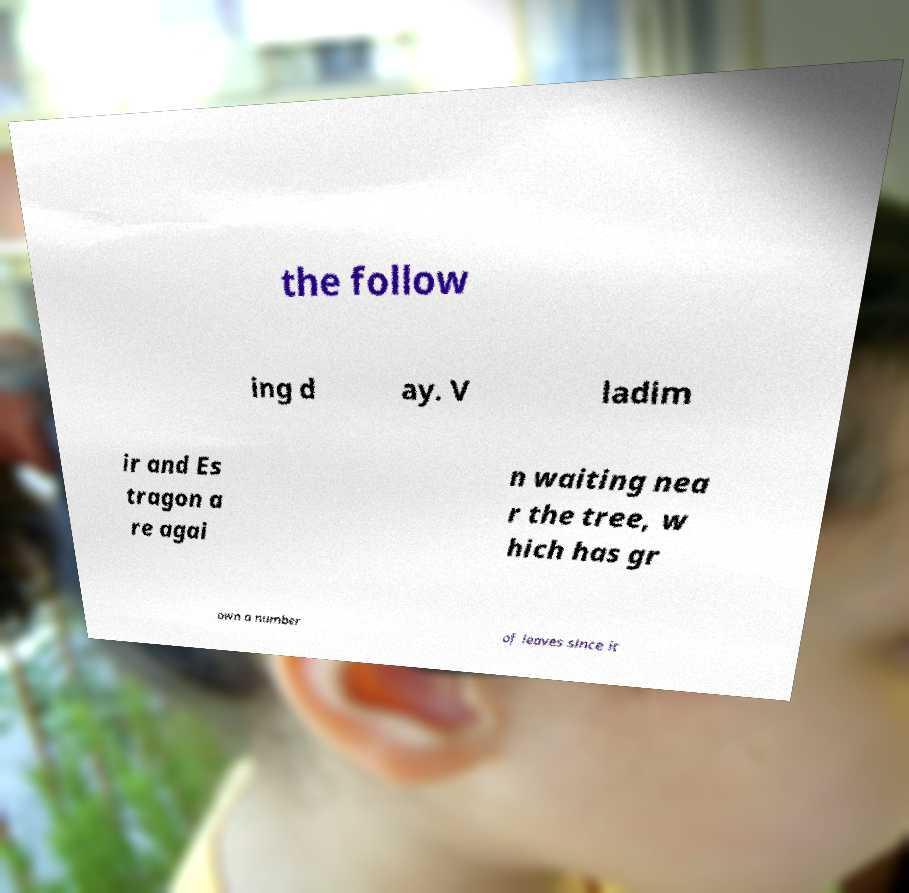Could you extract and type out the text from this image? the follow ing d ay. V ladim ir and Es tragon a re agai n waiting nea r the tree, w hich has gr own a number of leaves since it 